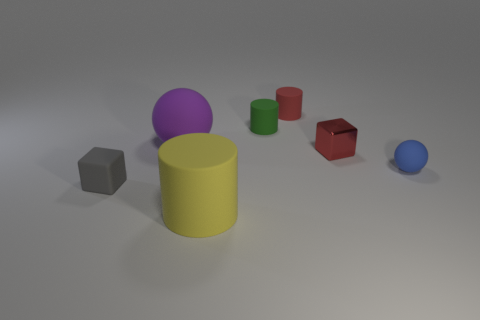How many objects are there in total, and can you describe their arrangement? In the image, there are seven objects in total, including two spheres, three cylinders, and two cubes. Starting from the left, there is a gray cube, followed by a large purple sphere and smaller green and red cylinders. In the foreground, there is a large yellow cylinder, behind which there is a small red cube and further back, a small blue sphere.  Which object stands out the most due to its size or color? The yellow cylinder stands out due to its size and its bright, vibrant color, which draws attention amidst the other, smaller objects. 